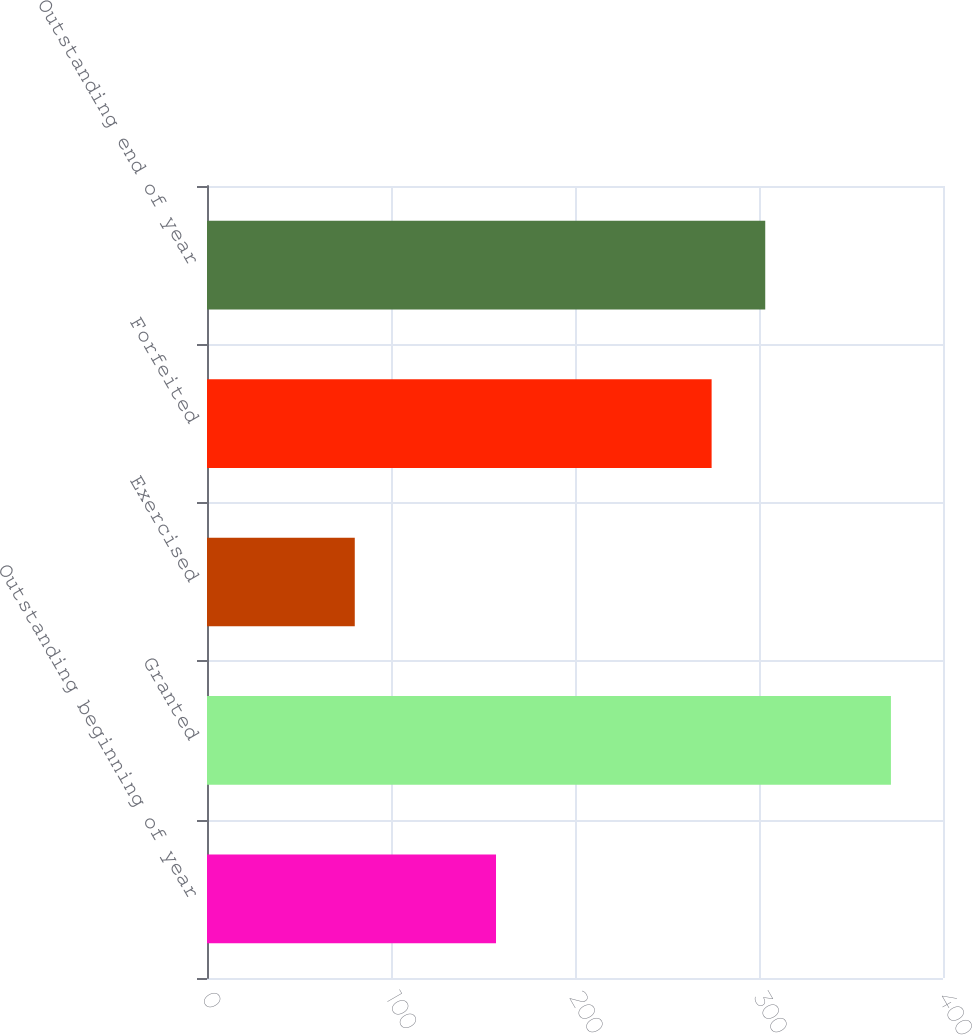Convert chart. <chart><loc_0><loc_0><loc_500><loc_500><bar_chart><fcel>Outstanding beginning of year<fcel>Granted<fcel>Exercised<fcel>Forfeited<fcel>Outstanding end of year<nl><fcel>157.07<fcel>371.7<fcel>80.31<fcel>274.25<fcel>303.39<nl></chart> 